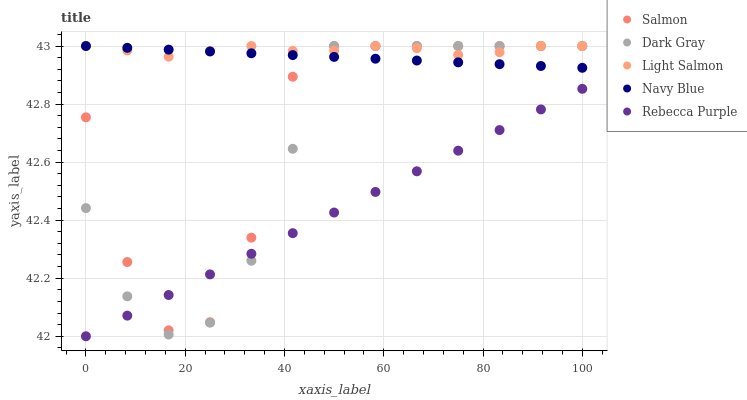Does Rebecca Purple have the minimum area under the curve?
Answer yes or no. Yes. Does Light Salmon have the maximum area under the curve?
Answer yes or no. Yes. Does Navy Blue have the minimum area under the curve?
Answer yes or no. No. Does Navy Blue have the maximum area under the curve?
Answer yes or no. No. Is Navy Blue the smoothest?
Answer yes or no. Yes. Is Salmon the roughest?
Answer yes or no. Yes. Is Light Salmon the smoothest?
Answer yes or no. No. Is Light Salmon the roughest?
Answer yes or no. No. Does Rebecca Purple have the lowest value?
Answer yes or no. Yes. Does Navy Blue have the lowest value?
Answer yes or no. No. Does Salmon have the highest value?
Answer yes or no. Yes. Does Rebecca Purple have the highest value?
Answer yes or no. No. Is Rebecca Purple less than Navy Blue?
Answer yes or no. Yes. Is Light Salmon greater than Rebecca Purple?
Answer yes or no. Yes. Does Light Salmon intersect Salmon?
Answer yes or no. Yes. Is Light Salmon less than Salmon?
Answer yes or no. No. Is Light Salmon greater than Salmon?
Answer yes or no. No. Does Rebecca Purple intersect Navy Blue?
Answer yes or no. No. 